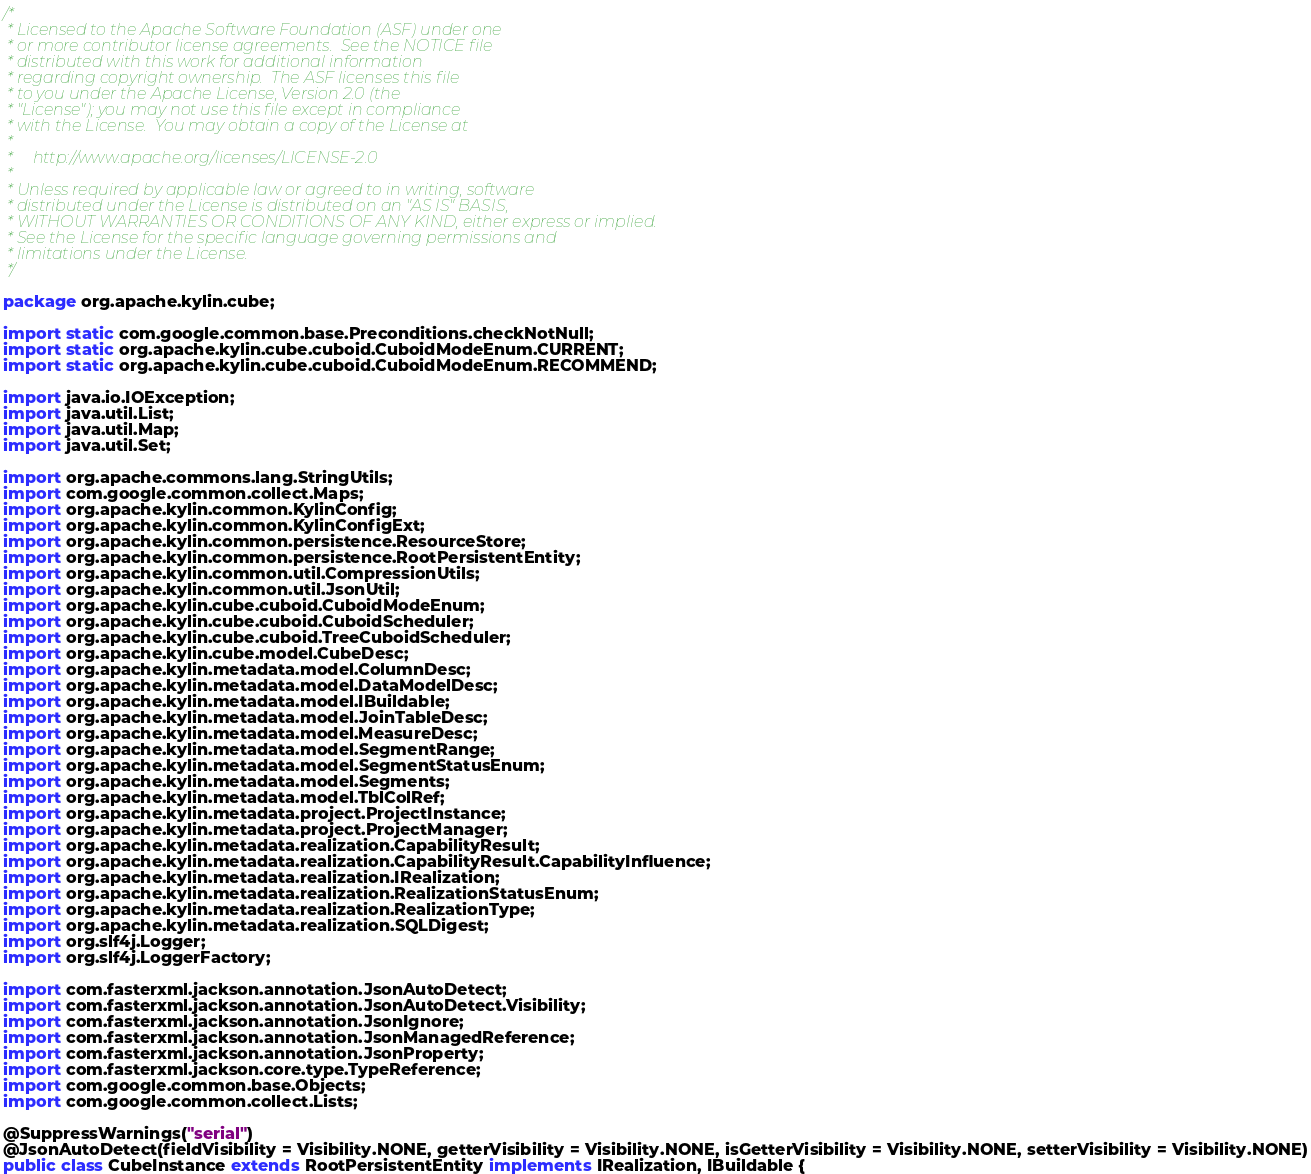<code> <loc_0><loc_0><loc_500><loc_500><_Java_>/*
 * Licensed to the Apache Software Foundation (ASF) under one
 * or more contributor license agreements.  See the NOTICE file
 * distributed with this work for additional information
 * regarding copyright ownership.  The ASF licenses this file
 * to you under the Apache License, Version 2.0 (the
 * "License"); you may not use this file except in compliance
 * with the License.  You may obtain a copy of the License at
 *
 *     http://www.apache.org/licenses/LICENSE-2.0
 *
 * Unless required by applicable law or agreed to in writing, software
 * distributed under the License is distributed on an "AS IS" BASIS,
 * WITHOUT WARRANTIES OR CONDITIONS OF ANY KIND, either express or implied.
 * See the License for the specific language governing permissions and
 * limitations under the License.
 */

package org.apache.kylin.cube;

import static com.google.common.base.Preconditions.checkNotNull;
import static org.apache.kylin.cube.cuboid.CuboidModeEnum.CURRENT;
import static org.apache.kylin.cube.cuboid.CuboidModeEnum.RECOMMEND;

import java.io.IOException;
import java.util.List;
import java.util.Map;
import java.util.Set;

import org.apache.commons.lang.StringUtils;
import com.google.common.collect.Maps;
import org.apache.kylin.common.KylinConfig;
import org.apache.kylin.common.KylinConfigExt;
import org.apache.kylin.common.persistence.ResourceStore;
import org.apache.kylin.common.persistence.RootPersistentEntity;
import org.apache.kylin.common.util.CompressionUtils;
import org.apache.kylin.common.util.JsonUtil;
import org.apache.kylin.cube.cuboid.CuboidModeEnum;
import org.apache.kylin.cube.cuboid.CuboidScheduler;
import org.apache.kylin.cube.cuboid.TreeCuboidScheduler;
import org.apache.kylin.cube.model.CubeDesc;
import org.apache.kylin.metadata.model.ColumnDesc;
import org.apache.kylin.metadata.model.DataModelDesc;
import org.apache.kylin.metadata.model.IBuildable;
import org.apache.kylin.metadata.model.JoinTableDesc;
import org.apache.kylin.metadata.model.MeasureDesc;
import org.apache.kylin.metadata.model.SegmentRange;
import org.apache.kylin.metadata.model.SegmentStatusEnum;
import org.apache.kylin.metadata.model.Segments;
import org.apache.kylin.metadata.model.TblColRef;
import org.apache.kylin.metadata.project.ProjectInstance;
import org.apache.kylin.metadata.project.ProjectManager;
import org.apache.kylin.metadata.realization.CapabilityResult;
import org.apache.kylin.metadata.realization.CapabilityResult.CapabilityInfluence;
import org.apache.kylin.metadata.realization.IRealization;
import org.apache.kylin.metadata.realization.RealizationStatusEnum;
import org.apache.kylin.metadata.realization.RealizationType;
import org.apache.kylin.metadata.realization.SQLDigest;
import org.slf4j.Logger;
import org.slf4j.LoggerFactory;

import com.fasterxml.jackson.annotation.JsonAutoDetect;
import com.fasterxml.jackson.annotation.JsonAutoDetect.Visibility;
import com.fasterxml.jackson.annotation.JsonIgnore;
import com.fasterxml.jackson.annotation.JsonManagedReference;
import com.fasterxml.jackson.annotation.JsonProperty;
import com.fasterxml.jackson.core.type.TypeReference;
import com.google.common.base.Objects;
import com.google.common.collect.Lists;

@SuppressWarnings("serial")
@JsonAutoDetect(fieldVisibility = Visibility.NONE, getterVisibility = Visibility.NONE, isGetterVisibility = Visibility.NONE, setterVisibility = Visibility.NONE)
public class CubeInstance extends RootPersistentEntity implements IRealization, IBuildable {</code> 